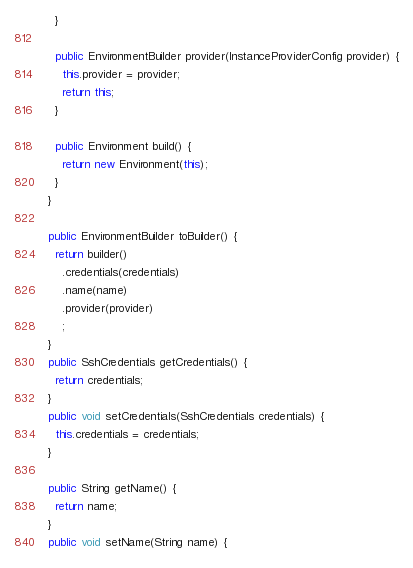<code> <loc_0><loc_0><loc_500><loc_500><_Java_>    }

    public EnvironmentBuilder provider(InstanceProviderConfig provider) {
      this.provider = provider;
      return this;
    }

    public Environment build() {
      return new Environment(this);
    }
  }

  public EnvironmentBuilder toBuilder() {
    return builder()
      .credentials(credentials)
      .name(name)
      .provider(provider)
      ;
  }
  public SshCredentials getCredentials() {
    return credentials;
  }
  public void setCredentials(SshCredentials credentials) {
    this.credentials = credentials;
  }

  public String getName() {
    return name;
  }
  public void setName(String name) {</code> 